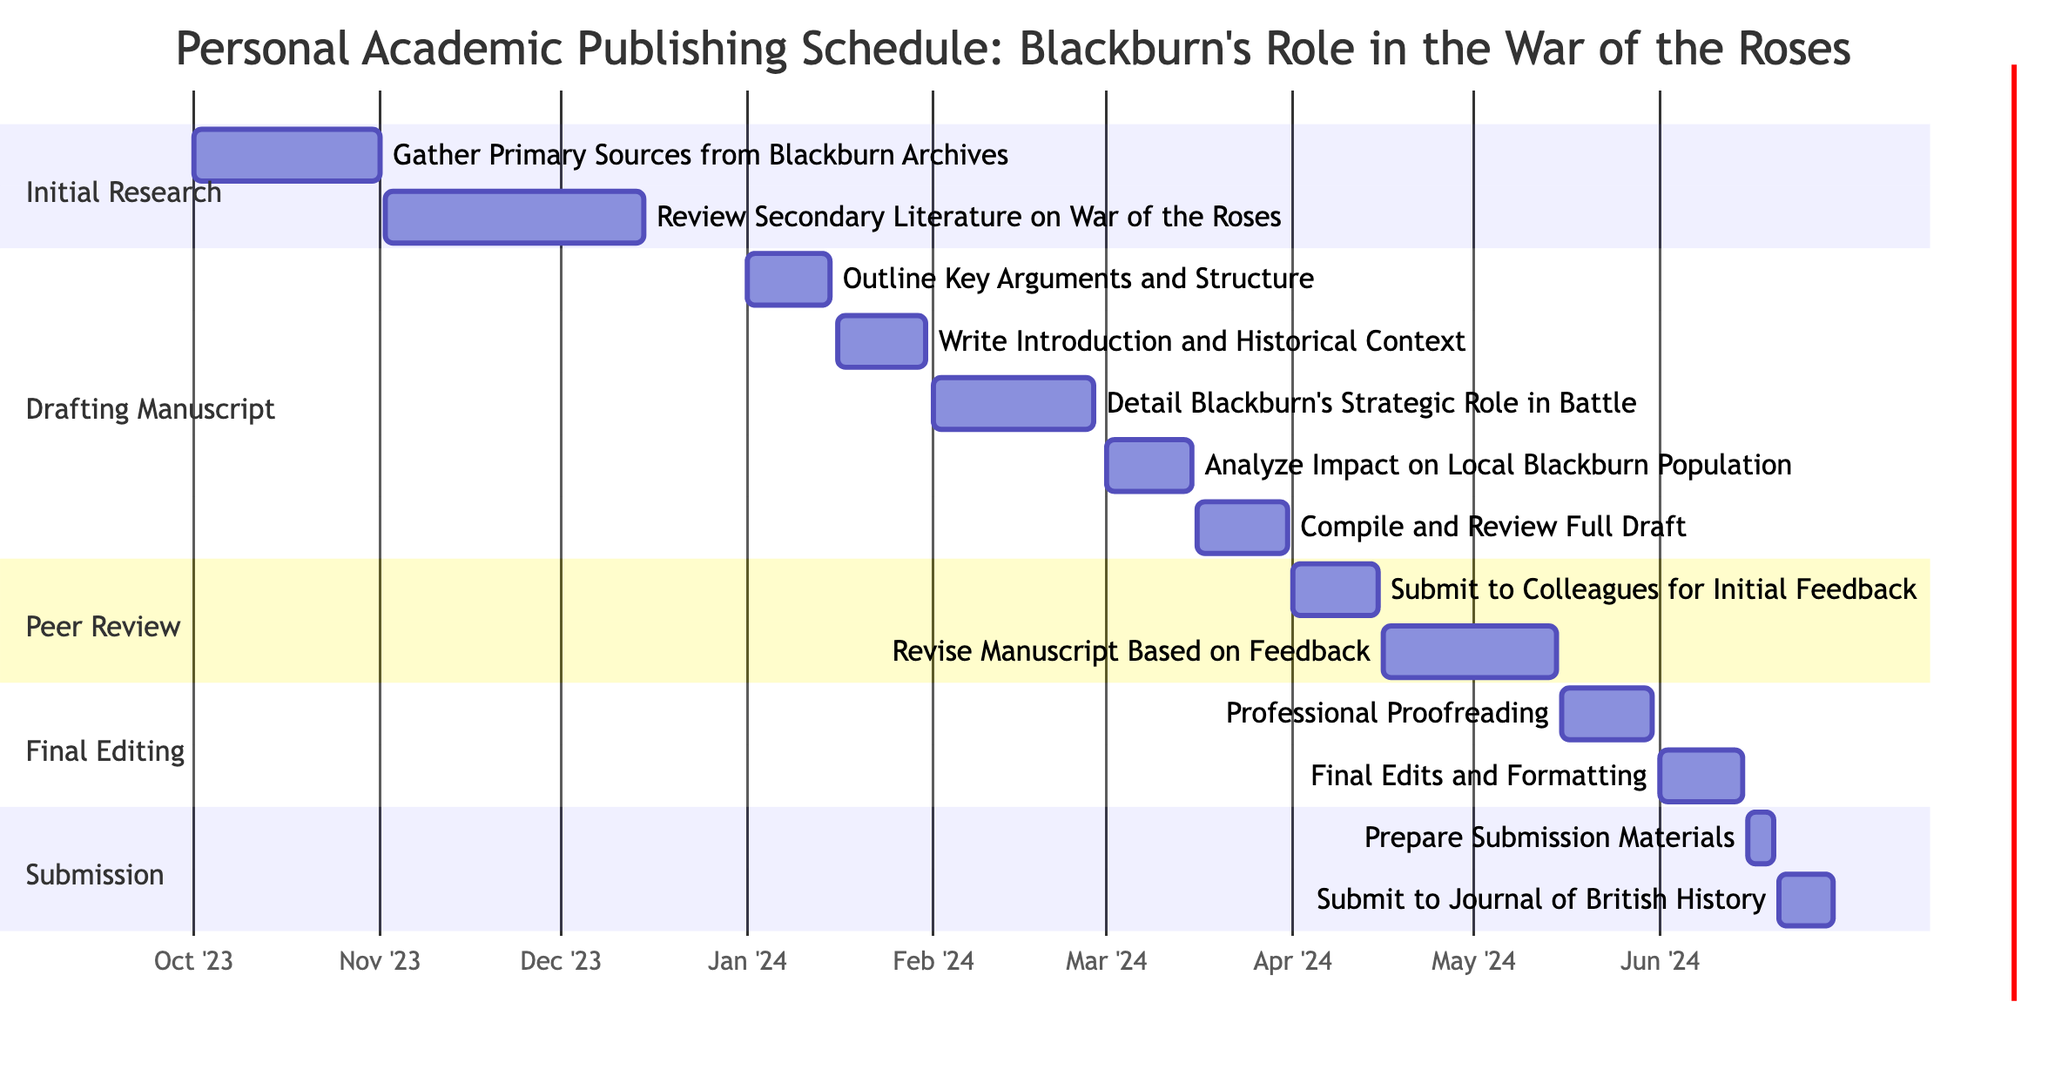What is the total duration of the "Drafting the Manuscript" phase? The "Drafting the Manuscript" phase starts on January 1, 2024, and ends on March 31, 2024. To calculate the duration, we take the end date and subtract the start date, giving us a total of 90 days.
Answer: 90 days What task follows "Review Secondary Literature on War of the Roses"? After "Review Secondary Literature on War of the Roses," the next task is "Outline Key Arguments and Structure," which starts on January 1, 2024.
Answer: Outline Key Arguments and Structure How many subtasks are there in the "Final Editing and Proofreading" section? In the "Final Editing and Proofreading" section, there are two subtasks: "Professional Proofreading" and "Final Edits and Formatting." Thus, the total count is two.
Answer: 2 When does the "Submit to Journal of British History" task begin? The task "Submit to Journal of British History" starts on June 21, 2024. This information is indicated clearly in the section labeled "Submission."
Answer: June 21, 2024 What is the overlap between the "Gather Primary Sources from Blackburn Archives" and "Outline Key Arguments and Structure" tasks? "Gather Primary Sources from Blackburn Archives" ends on November 1, 2023, while "Outline Key Arguments and Structure" starts on January 1, 2024. There is no overlap because the first task ends before the second begins.
Answer: No overlap How many tasks are in the "Peer Review and Feedback" section? The "Peer Review and Feedback" section contains two tasks: "Submit to Colleagues for Initial Feedback" and "Revise Manuscript Based on Feedback." Thus, the count is two tasks.
Answer: 2 tasks What is the last date for "Final Edits and Formatting"? The task "Final Edits and Formatting" ends on June 15, 2024, marking it as the last date in that phase of the Gantt chart.
Answer: June 15, 2024 Which task takes the longest time within the "Drafting the Manuscript" phase? The task "Detail Blackburn's Strategic Role in Battle" spans from February 1, 2024, to February 28, 2024. The duration of this task is 28 days, making it the longest.
Answer: Detail Blackburn's Strategic Role in Battle 